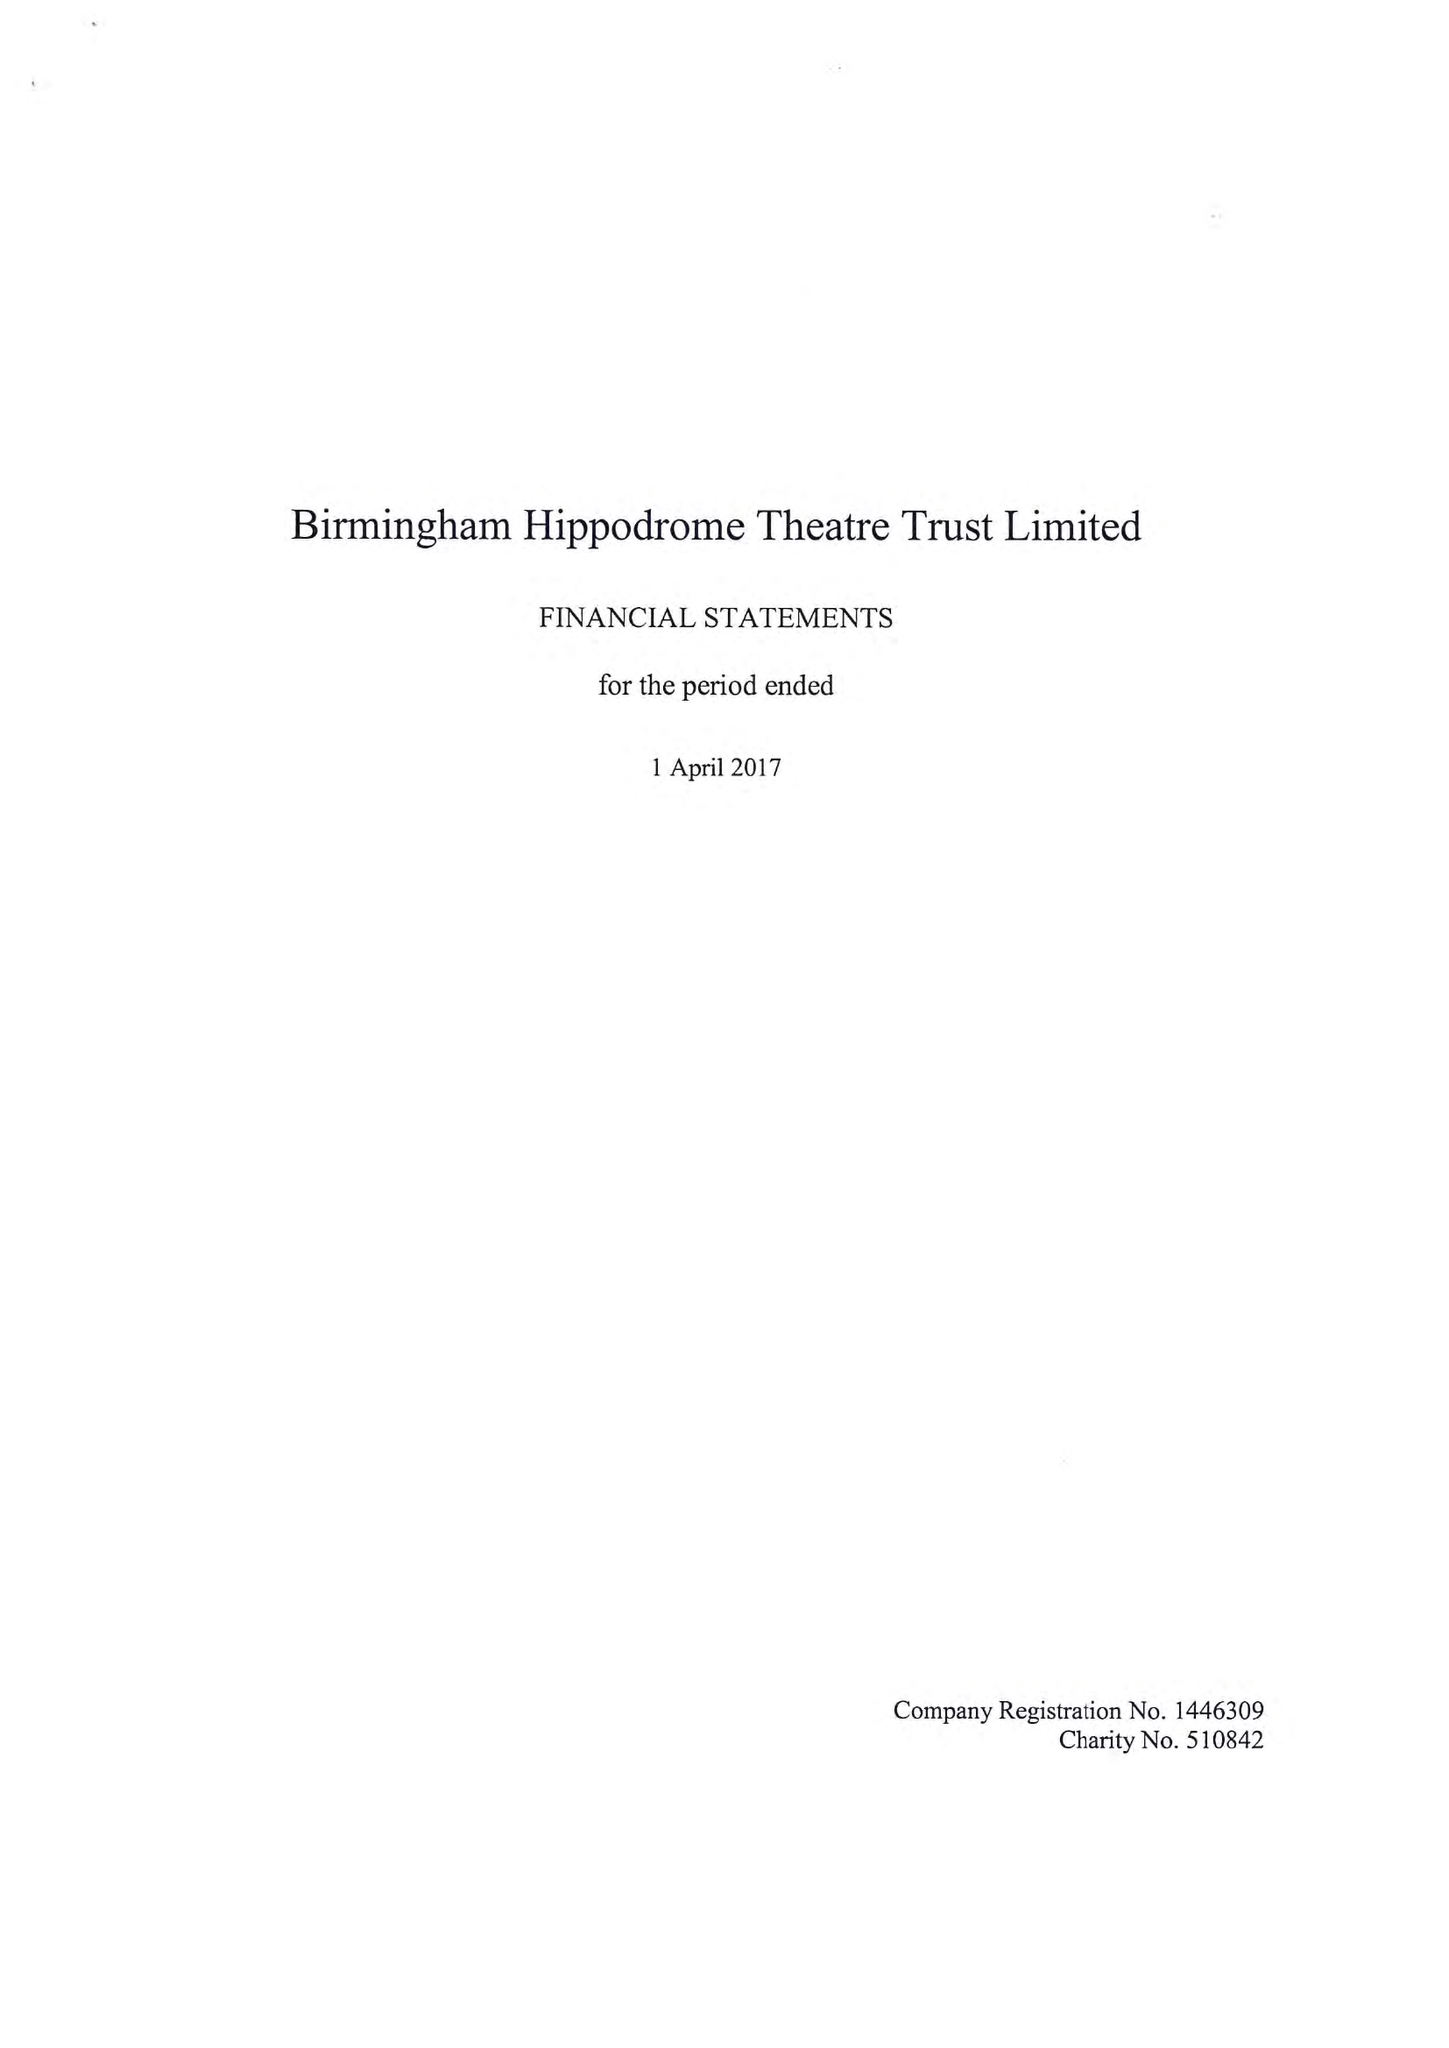What is the value for the report_date?
Answer the question using a single word or phrase. 2017-04-01 